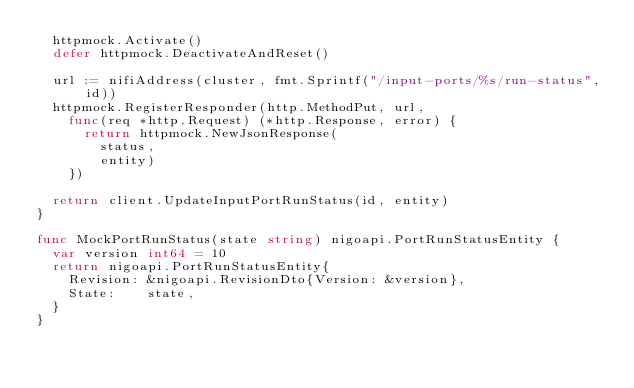<code> <loc_0><loc_0><loc_500><loc_500><_Go_>	httpmock.Activate()
	defer httpmock.DeactivateAndReset()

	url := nifiAddress(cluster, fmt.Sprintf("/input-ports/%s/run-status", id))
	httpmock.RegisterResponder(http.MethodPut, url,
		func(req *http.Request) (*http.Response, error) {
			return httpmock.NewJsonResponse(
				status,
				entity)
		})

	return client.UpdateInputPortRunStatus(id, entity)
}

func MockPortRunStatus(state string) nigoapi.PortRunStatusEntity {
	var version int64 = 10
	return nigoapi.PortRunStatusEntity{
		Revision: &nigoapi.RevisionDto{Version: &version},
		State:    state,
	}
}
</code> 